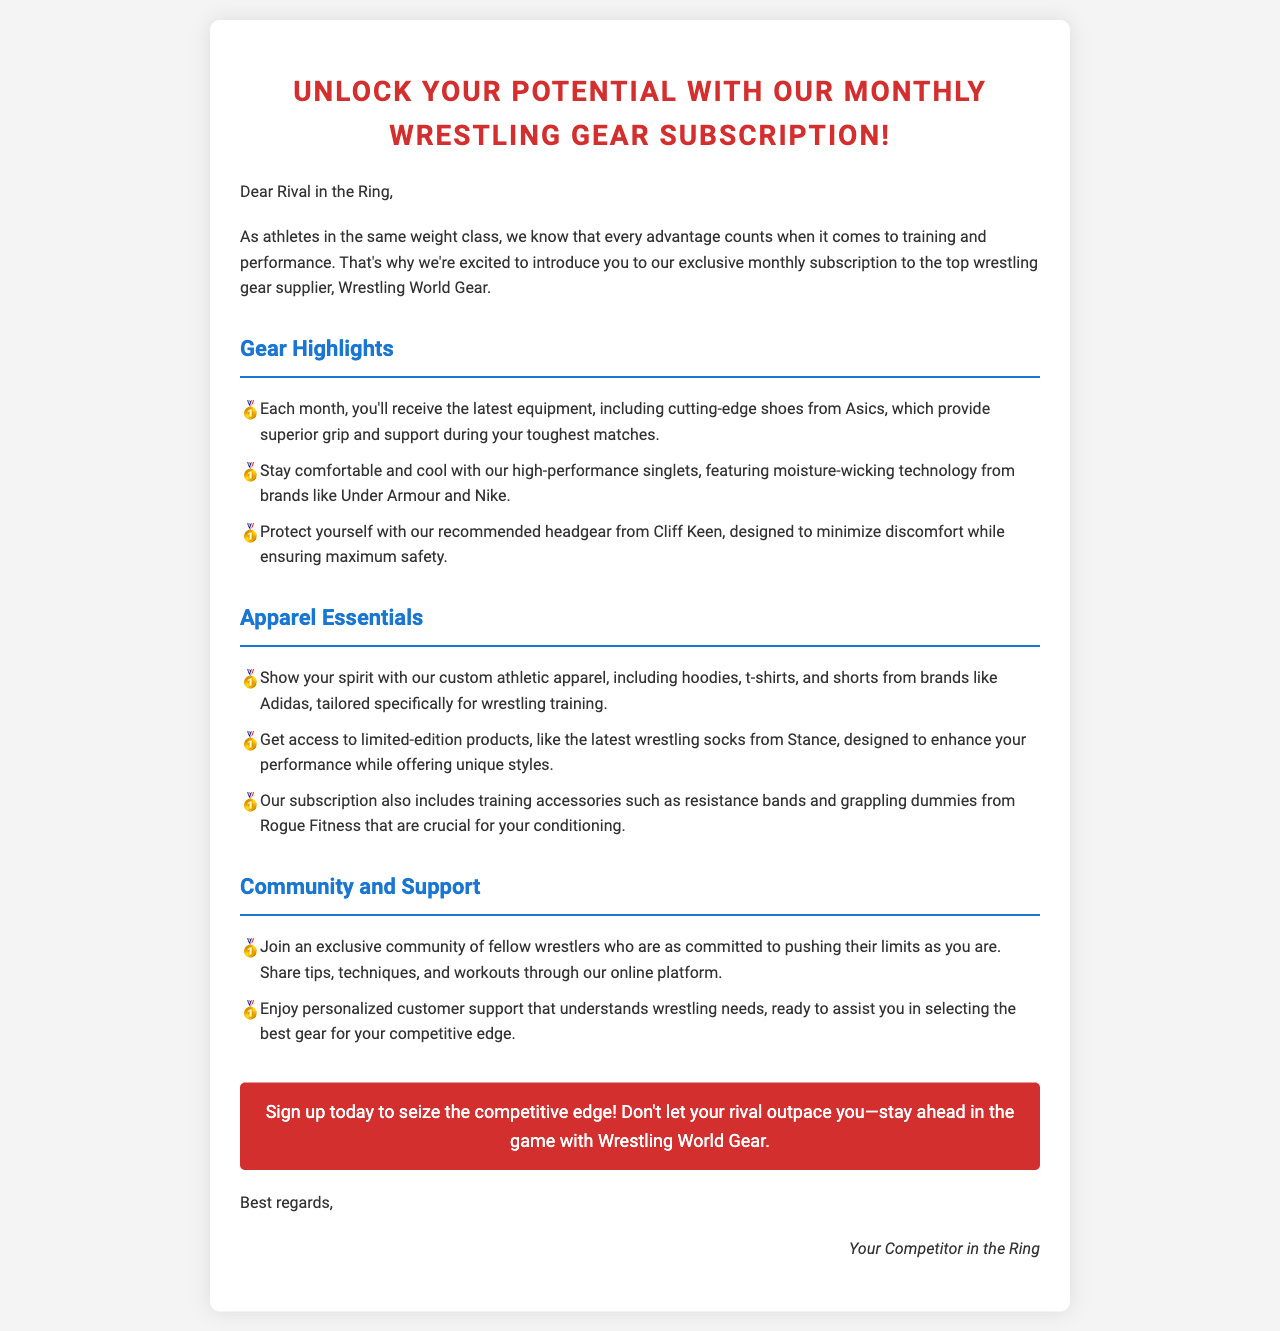What is the title of the document? The title is presented prominently in the header section of the mail.
Answer: Unlock Your Potential with Our Monthly Wrestling Gear Subscription! Who is the sender addressing in the greeting? The sender uses a specific phrase indicating the recipient's role in relation to them, as noted in the greeting.
Answer: Rival in the Ring What brand of shoes is featured in the gear highlights? The document specifically mentions a particular brand that provides equipment.
Answer: Asics What type of technology is featured in the high-performance singlets? The document describes a specific feature of the singlets that is key to their performance.
Answer: Moisture-wicking technology Which brand is associated with the recommended headgear? The mail identifies a particular brand for headgear that wrestlers can use for safety.
Answer: Cliff Keen What is one of the benefits of the monthly subscription? One of the key advantages mentioned relates to a competitive aspect of wrestling.
Answer: Access to the latest equipment What community feature is highlighted in the document? The text describes a community aspect central to the subscription service.
Answer: Exclusive community of fellow wrestlers What is the call to action at the end of the document? The document includes a specific encouragement towards engagement with the service, found in a highlighted button.
Answer: Sign up today to seize the competitive edge! 